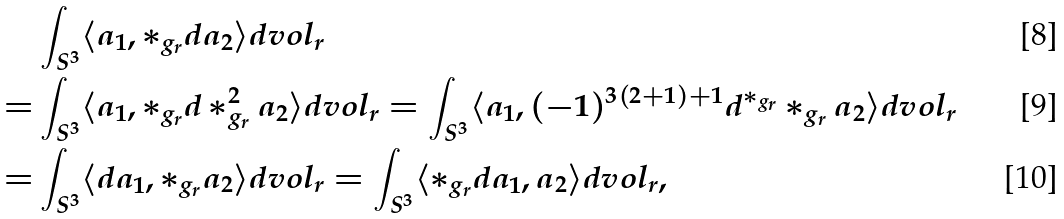<formula> <loc_0><loc_0><loc_500><loc_500>& \int _ { S ^ { 3 } } \langle a _ { 1 } , * _ { g _ { r } } d a _ { 2 } \rangle d v o l _ { r } \\ = & \int _ { S ^ { 3 } } \langle a _ { 1 } , * _ { g _ { r } } d * _ { g _ { r } } ^ { 2 } a _ { 2 } \rangle d v o l _ { r } = \int _ { S ^ { 3 } } \langle a _ { 1 } , ( - 1 ) ^ { 3 ( 2 + 1 ) + 1 } d ^ { * _ { g _ { r } } } * _ { g _ { r } } a _ { 2 } \rangle d v o l _ { r } \\ = & \int _ { S ^ { 3 } } \langle d a _ { 1 } , * _ { g _ { r } } a _ { 2 } \rangle d v o l _ { r } = \int _ { S ^ { 3 } } \langle * _ { g _ { r } } d a _ { 1 } , a _ { 2 } \rangle d v o l _ { r } ,</formula> 